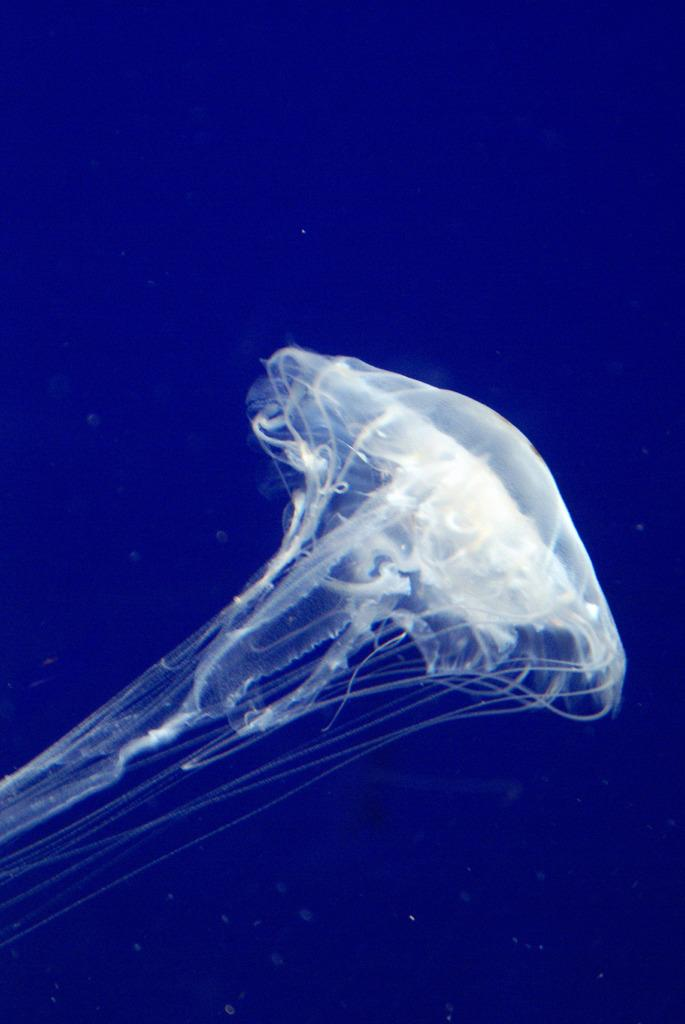What is the main subject of the picture? The main subject of the picture is a white jellyfish. What color is the background of the image? The background of the image is blue in color. How many trucks are visible in the image? There are no trucks present in the image; it features a white jellyfish against a blue background. What type of discovery can be made in the image? There is no discovery to be made in the image; it simply shows a white jellyfish against a blue background. 